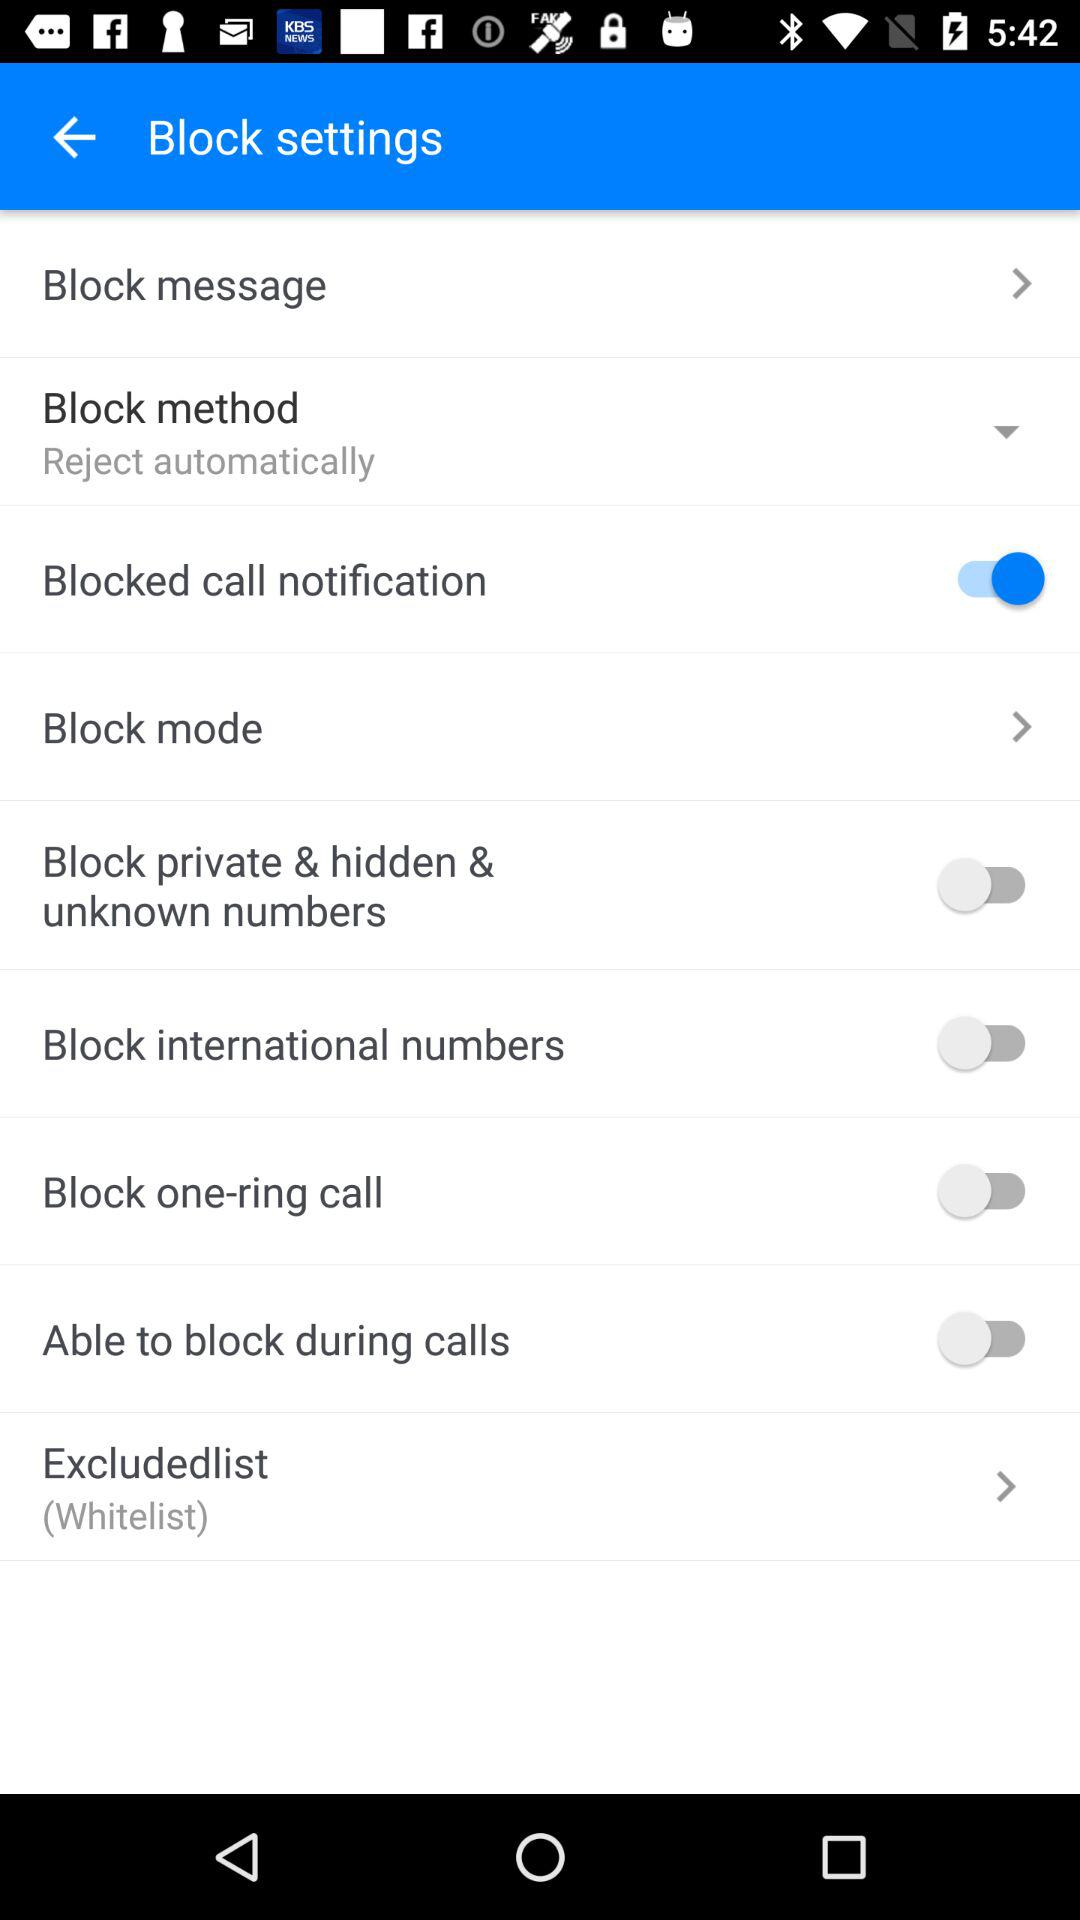What is the status of Block mode?
When the provided information is insufficient, respond with <no answer>. <no answer> 